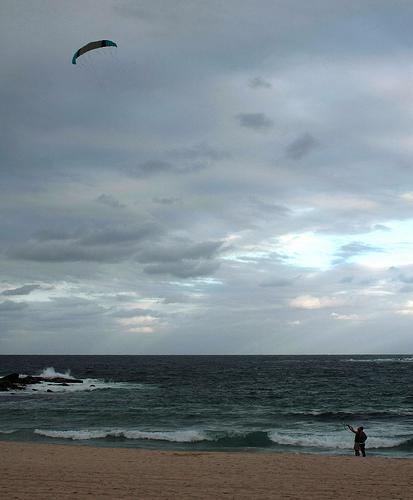Question: what color are the clouds?
Choices:
A. White.
B. Black.
C. Blue.
D. Grey.
Answer with the letter. Answer: D Question: what is the weather?
Choices:
A. Hot.
B. Cold.
C. There is freezing rain.
D. Cloudy.
Answer with the letter. Answer: D Question: what are in the water?
Choices:
A. Waves.
B. Fish.
C. Seaweed.
D. Plankton.
Answer with the letter. Answer: A Question: what type of scene is this?
Choices:
A. Outside a cabin in the mountains.
B. Next to a large lake.
C. Outdoor.
D. In an office.
Answer with the letter. Answer: C Question: where is this scene?
Choices:
A. Beach.
B. In a football stadium.
C. In a coffee shop.
D. In a cemetary.
Answer with the letter. Answer: A Question: who is in the photo?
Choices:
A. A person.
B. Brad Pitt and Angelina Jolie.
C. My family.
D. Some stranger who I don't know.
Answer with the letter. Answer: A 